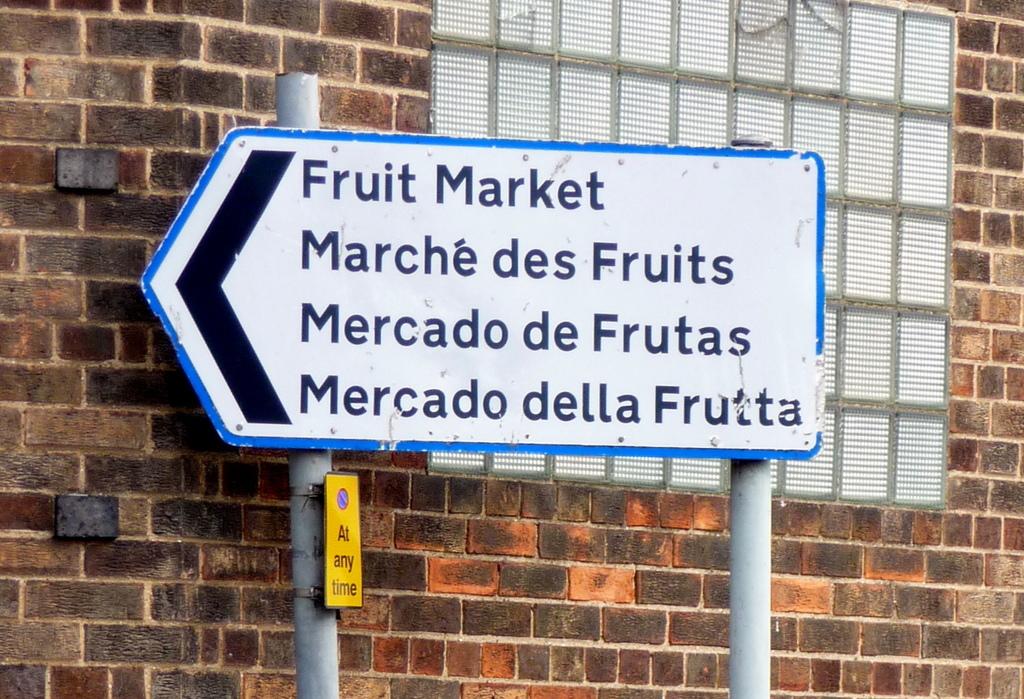What is in the direction of the arrow?
Your answer should be very brief. Left. What is on first line on the sign?
Make the answer very short. Fruit market. 